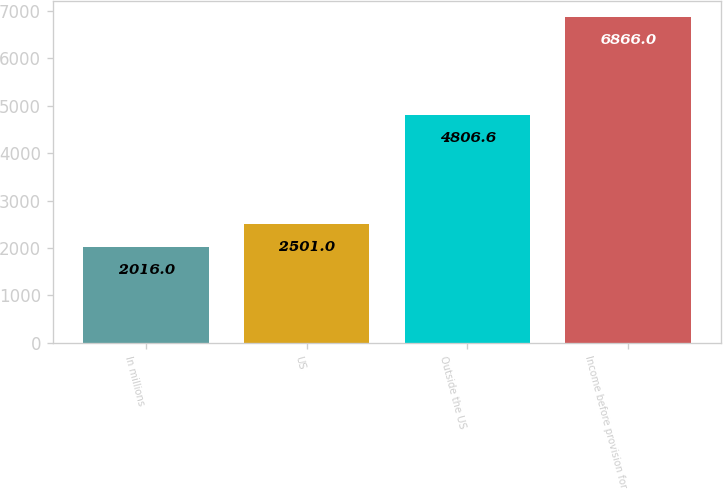Convert chart. <chart><loc_0><loc_0><loc_500><loc_500><bar_chart><fcel>In millions<fcel>US<fcel>Outside the US<fcel>Income before provision for<nl><fcel>2016<fcel>2501<fcel>4806.6<fcel>6866<nl></chart> 